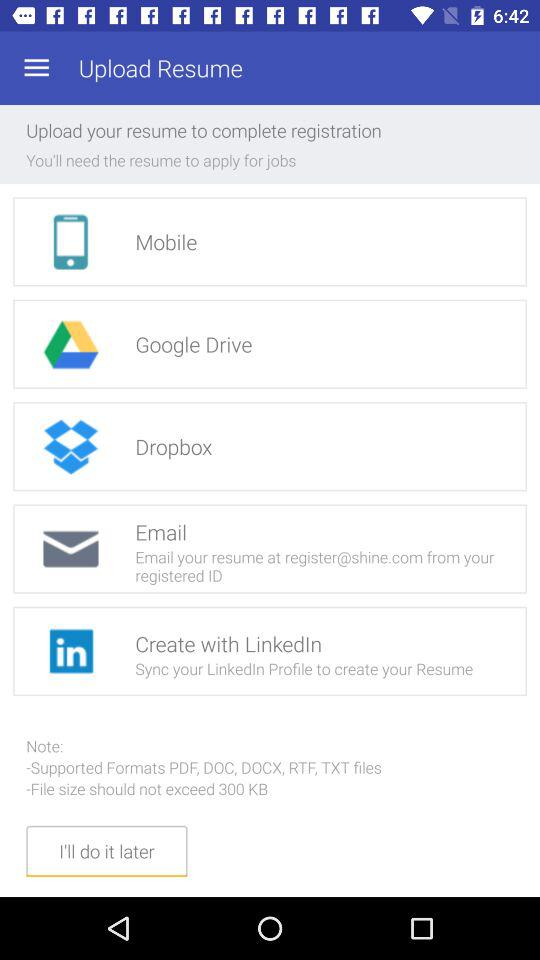What shouldn't the file size be? The file size shouldn't be more than 300 KB. 